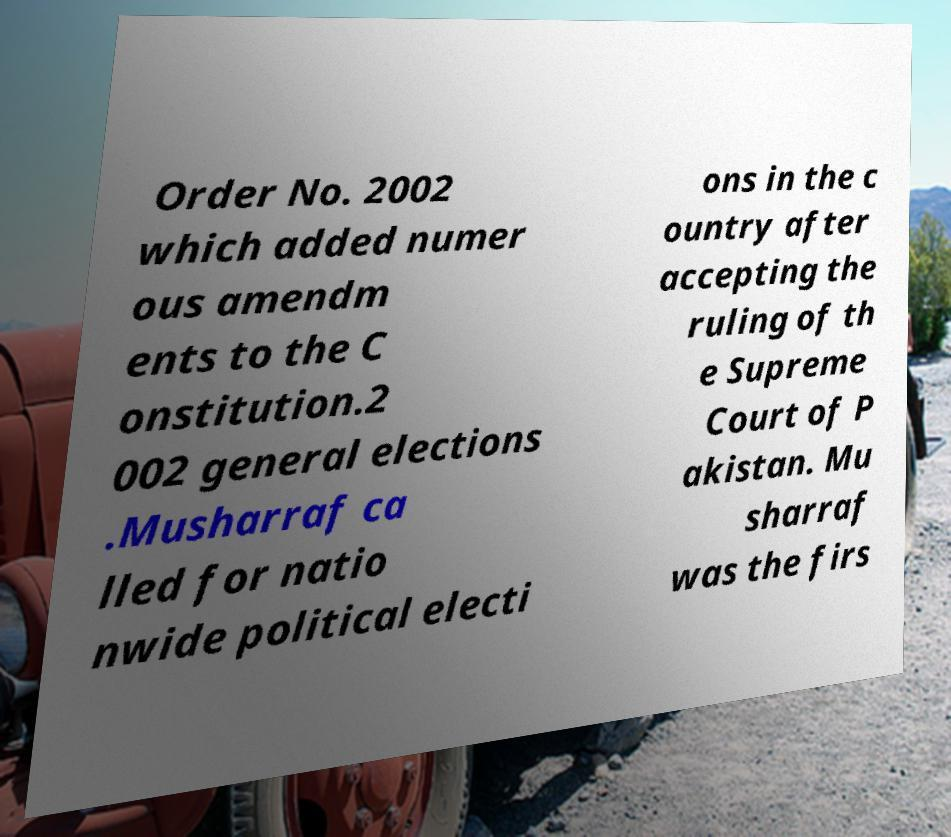Please identify and transcribe the text found in this image. Order No. 2002 which added numer ous amendm ents to the C onstitution.2 002 general elections .Musharraf ca lled for natio nwide political electi ons in the c ountry after accepting the ruling of th e Supreme Court of P akistan. Mu sharraf was the firs 